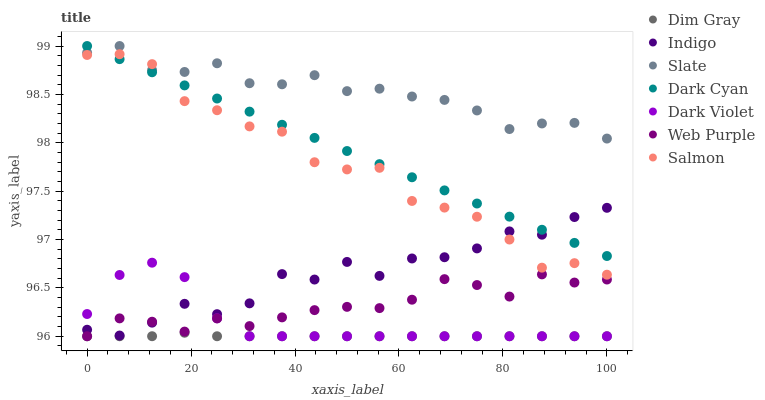Does Dim Gray have the minimum area under the curve?
Answer yes or no. Yes. Does Slate have the maximum area under the curve?
Answer yes or no. Yes. Does Indigo have the minimum area under the curve?
Answer yes or no. No. Does Indigo have the maximum area under the curve?
Answer yes or no. No. Is Dark Cyan the smoothest?
Answer yes or no. Yes. Is Indigo the roughest?
Answer yes or no. Yes. Is Slate the smoothest?
Answer yes or no. No. Is Slate the roughest?
Answer yes or no. No. Does Dim Gray have the lowest value?
Answer yes or no. Yes. Does Indigo have the lowest value?
Answer yes or no. No. Does Dark Cyan have the highest value?
Answer yes or no. Yes. Does Indigo have the highest value?
Answer yes or no. No. Is Indigo less than Slate?
Answer yes or no. Yes. Is Salmon greater than Dim Gray?
Answer yes or no. Yes. Does Dark Cyan intersect Indigo?
Answer yes or no. Yes. Is Dark Cyan less than Indigo?
Answer yes or no. No. Is Dark Cyan greater than Indigo?
Answer yes or no. No. Does Indigo intersect Slate?
Answer yes or no. No. 